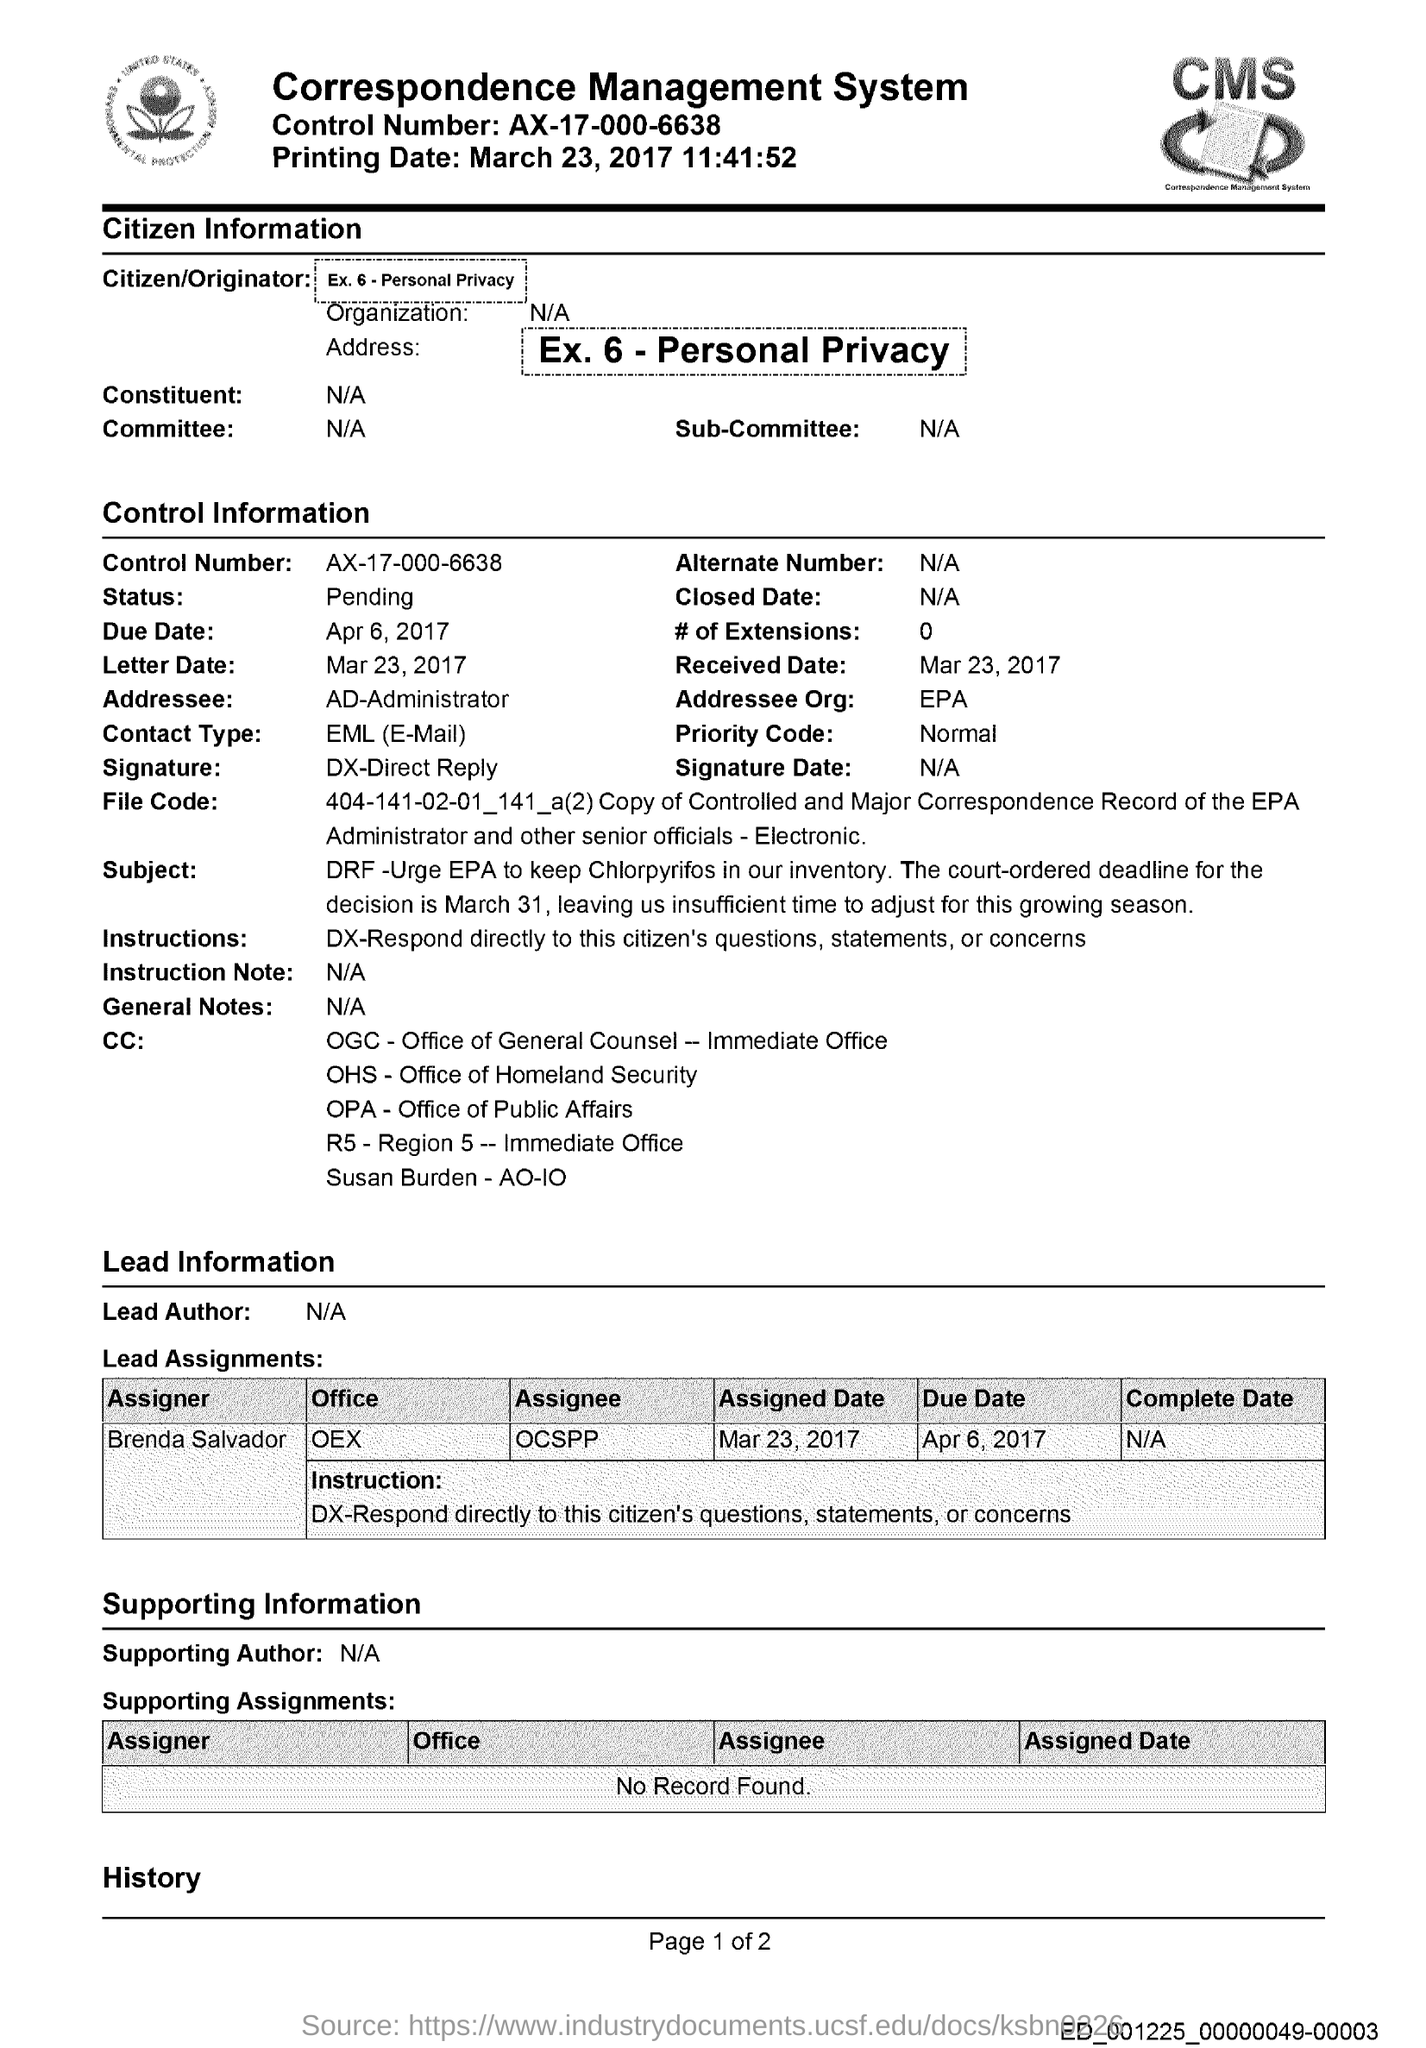What is the fullform of CMS?
Give a very brief answer. Correspondence Management System. What is the control number given in the document?
Your answer should be very brief. AX-17-000-6638. What is the printing date mentioned in the document?
Give a very brief answer. March 23, 2017. Who is the addressee as per the control information?
Your response must be concise. AD-Administrator. Which is the addressee organization mentioned in the document?
Provide a succinct answer. EPA. What is the priority code given in the document?
Offer a terse response. Normal. What is the contact type mentioned in the document?
Offer a very short reply. EML (E-mail). What is the letter date mentioned in the document?
Keep it short and to the point. Mar 23, 2017. What is the received date given in this document?
Your response must be concise. Mar 23, 2017. 